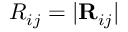<formula> <loc_0><loc_0><loc_500><loc_500>R _ { i j } = | { R } _ { i j } |</formula> 